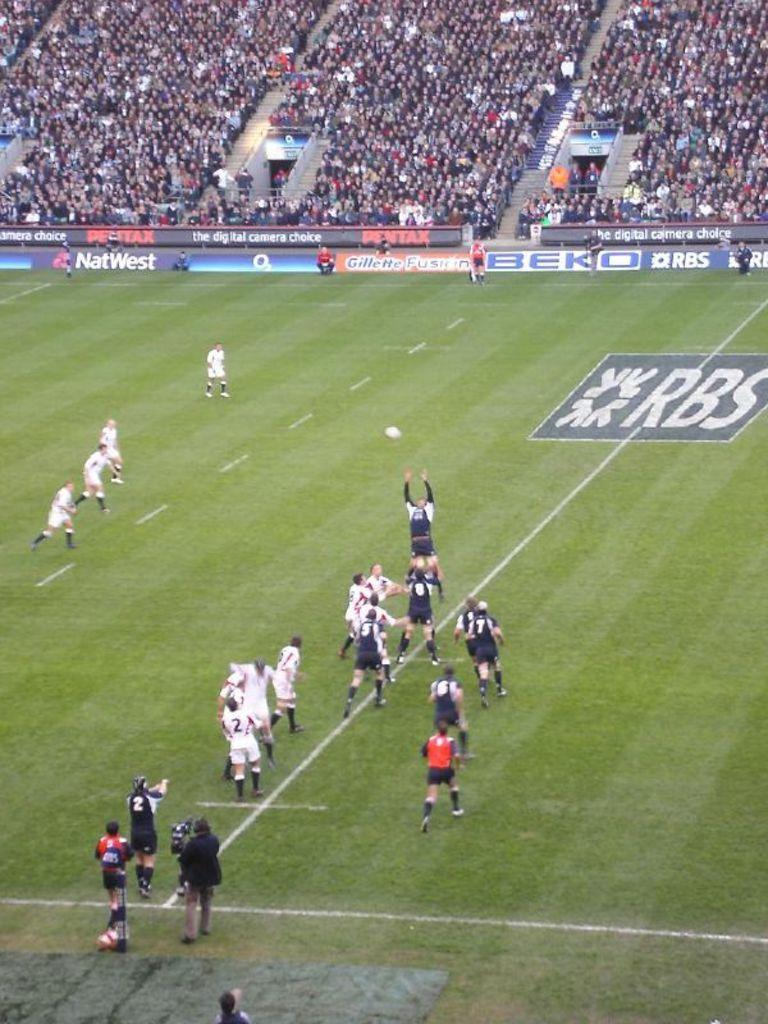<image>
Render a clear and concise summary of the photo. Two teams are competing in a soccer game with the letters RBS painted on the field. 